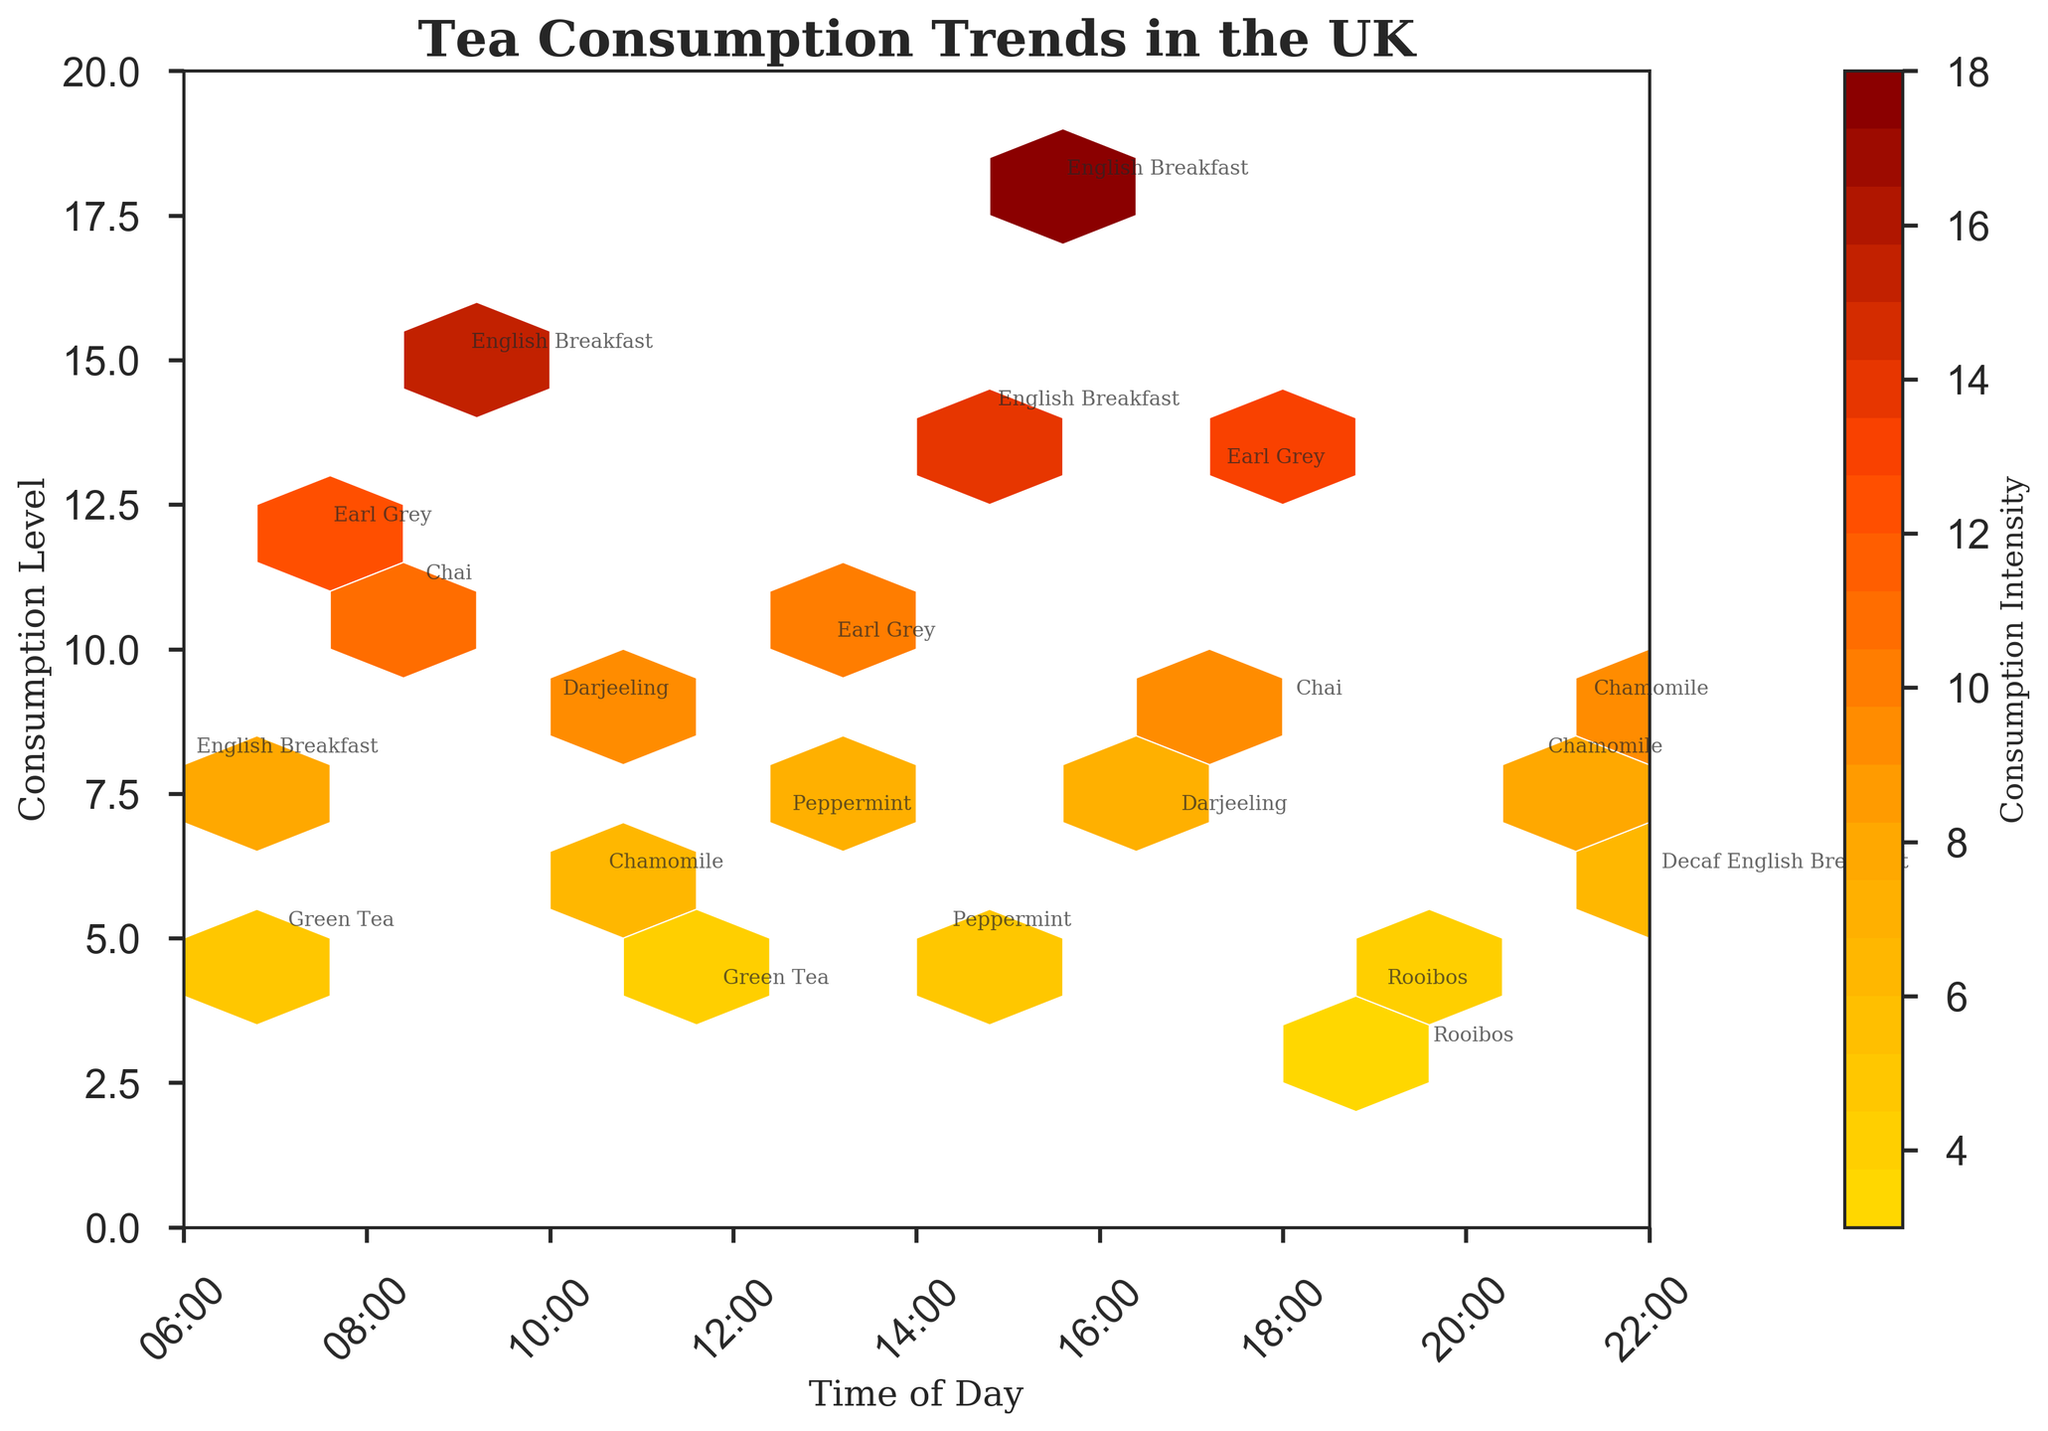What is the title of the plot? The title is usually in a larger font at the top of the plot. In this case, the title "Tea Consumption Trends in the UK" is displayed prominently at the top.
Answer: Tea Consumption Trends in the UK What does the color gradient on the plot represent? The color gradient on the plot shows the different intensities of tea consumption. Darker colors like dark red indicate higher consumption levels, while lighter colors like gold indicate lower consumption levels.
Answer: Consumption Intensity What are the labels on the x and y axes? The labels on the x and y axes typically explain what each axis represents. Here, the x-axis is labeled "Time of Day" and the y-axis is labeled "Consumption Level."
Answer: Time of Day, Consumption Level Which time of day shows the highest tea consumption in the plot? By observing the plot, the 15:30 mark (~3:30 PM) shows the highest consumption level, indicated by the darkest color on the hexbin.
Answer: 15:30 (~3:30 PM) How does tea consumption at 9:00 compare to consumption at 17:15? The plot marks tea consumption levels at different times. At 9:00, the consumption level is labeled 15, whereas at 17:15 it is labeled 13, indicating that 9:00 has a higher consumption level compared to 17:15.
Answer: 9:00 has higher consumption What is the range of time displayed on the x-axis? The x-axis range is indicated by the labels and ticks. The plot shows time from 6:00 to 22:00.
Answer: 6:00 to 22:00 Identify a tea type that is consumed both in the morning and evening. By checking the annotations, "Chamomile" is consumed at both 10:30 in the morning and 20:45 and 21:15 in the evening.
Answer: Chamomile Around what time of day do you see the lowest tea consumption? The plot shows that around 11:45, the consumption is labeled 4, which is among the lowest noticeable on the hexbin plot.
Answer: 11:45 Which tea type appears most frequently and at what times? "English Breakfast" tea appears most frequently and can be seen at times 6:00, 9:00, 15:30, and 14:45, making it the most common tea type on the plot.
Answer: English Breakfast at 6:00, 9:00, 15:30, 14:45 Compare the consumption of Chamomile tea at 10:30, 20:45, and 21:15. Which time shows the highest consumption? The plot marks Chamomile tea consumption levels at the three times: 6 at 10:30, 8 at 20:45, and 9 at 21:15. The highest consumption is at 21:15.
Answer: 21:15 